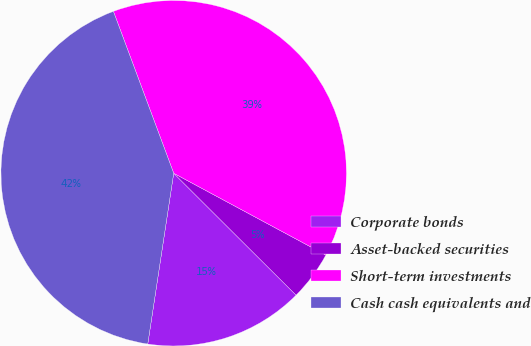<chart> <loc_0><loc_0><loc_500><loc_500><pie_chart><fcel>Corporate bonds<fcel>Asset-backed securities<fcel>Short-term investments<fcel>Cash cash equivalents and<nl><fcel>14.93%<fcel>4.62%<fcel>38.53%<fcel>41.93%<nl></chart> 